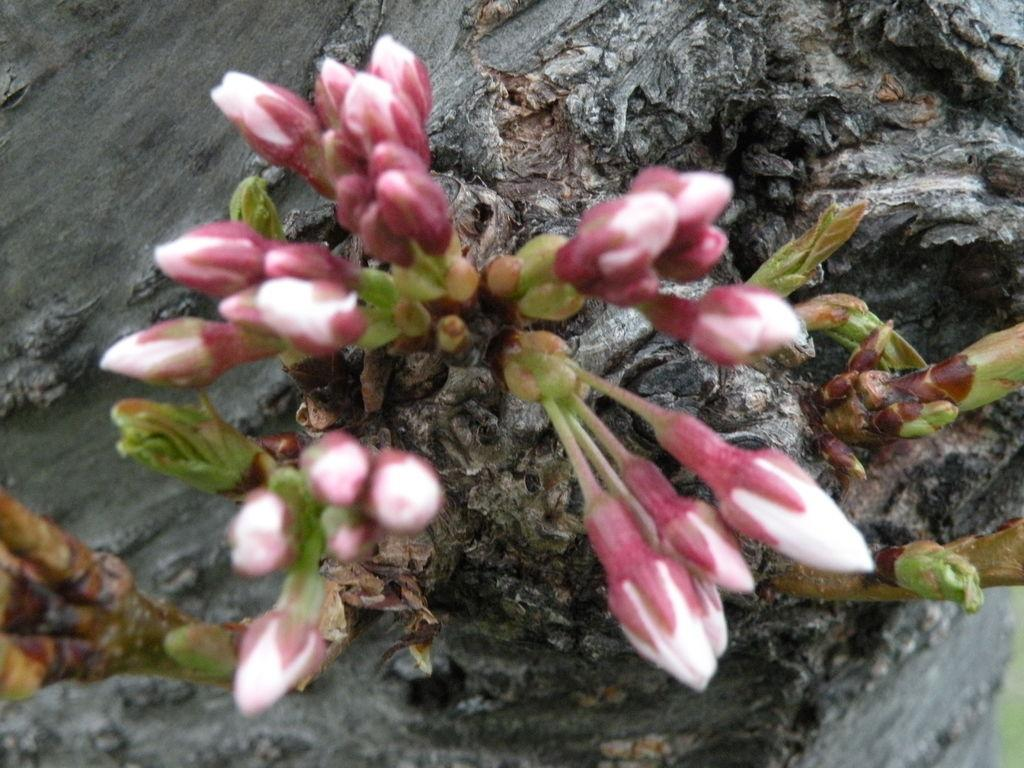What is present on the bark of the tree in the image? There are flower buds on the bark of a tree in the image. What type of sock is hanging from the tree in the image? There is no sock present in the image; it features flower buds on the bark of a tree. 